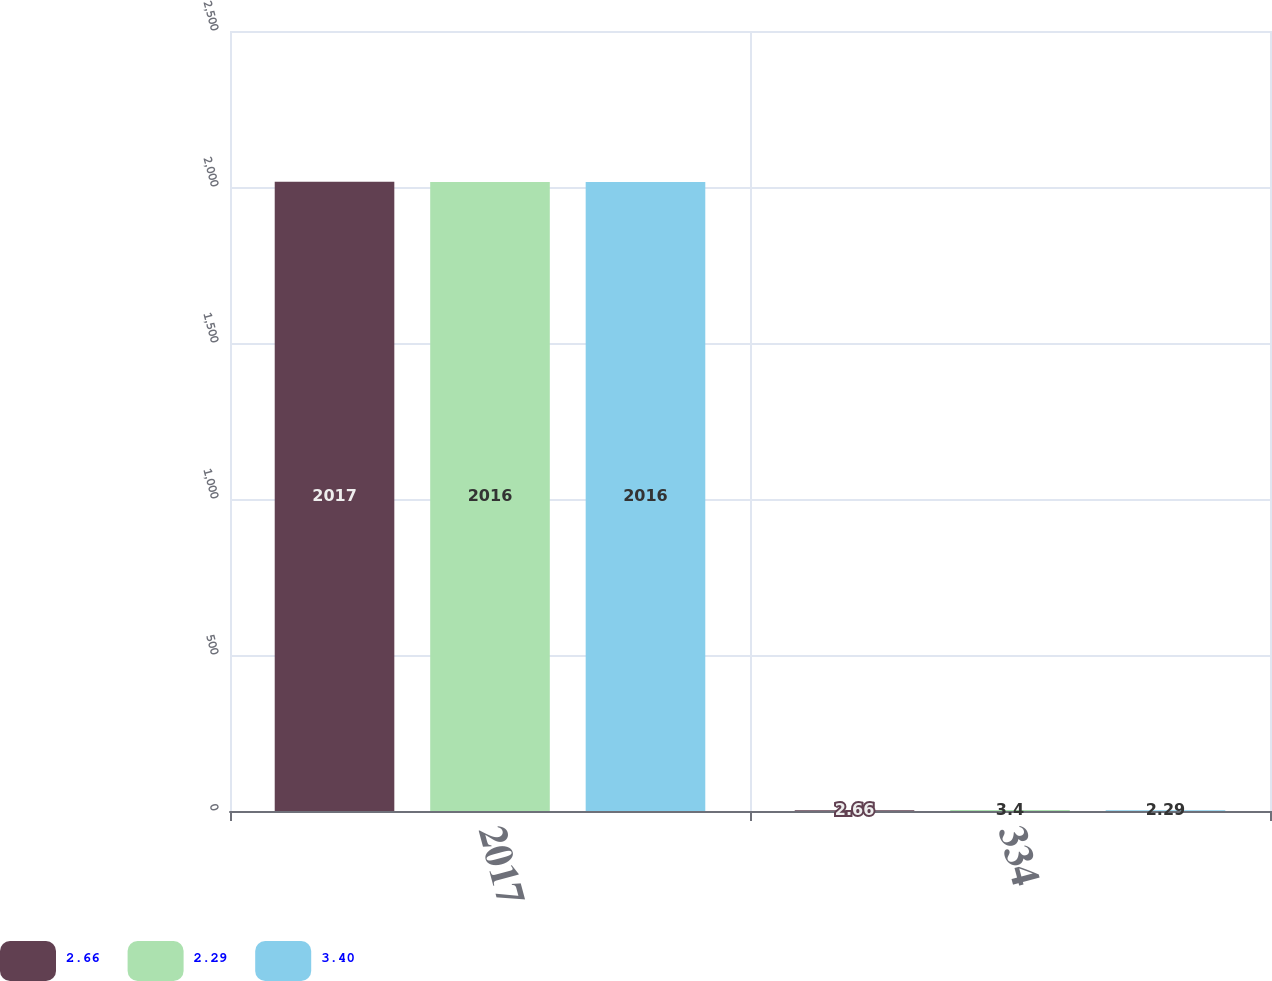Convert chart to OTSL. <chart><loc_0><loc_0><loc_500><loc_500><stacked_bar_chart><ecel><fcel>2017<fcel>334<nl><fcel>2.66<fcel>2017<fcel>2.66<nl><fcel>2.29<fcel>2016<fcel>3.4<nl><fcel>3.4<fcel>2016<fcel>2.29<nl></chart> 